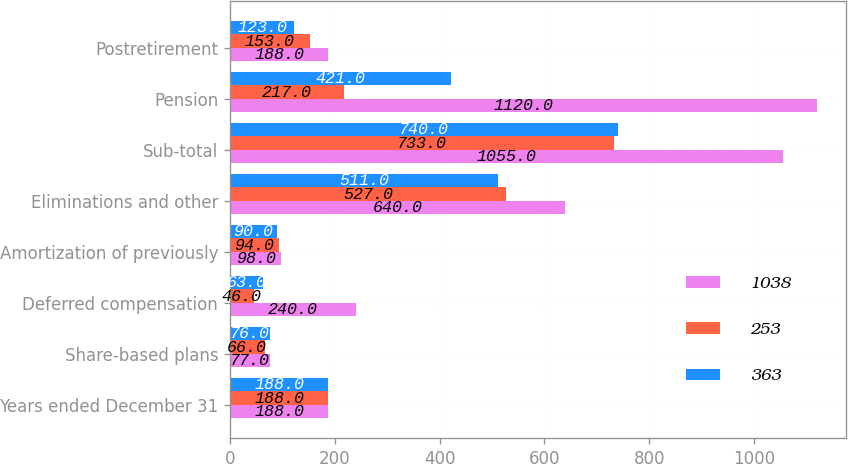Convert chart to OTSL. <chart><loc_0><loc_0><loc_500><loc_500><stacked_bar_chart><ecel><fcel>Years ended December 31<fcel>Share-based plans<fcel>Deferred compensation<fcel>Amortization of previously<fcel>Eliminations and other<fcel>Sub-total<fcel>Pension<fcel>Postretirement<nl><fcel>1038<fcel>188<fcel>77<fcel>240<fcel>98<fcel>640<fcel>1055<fcel>1120<fcel>188<nl><fcel>253<fcel>188<fcel>66<fcel>46<fcel>94<fcel>527<fcel>733<fcel>217<fcel>153<nl><fcel>363<fcel>188<fcel>76<fcel>63<fcel>90<fcel>511<fcel>740<fcel>421<fcel>123<nl></chart> 